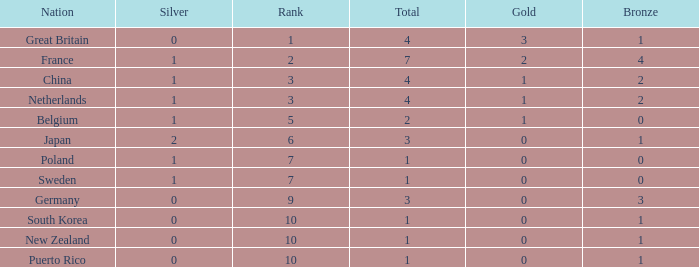What is the rank with 0 bronze? None. 